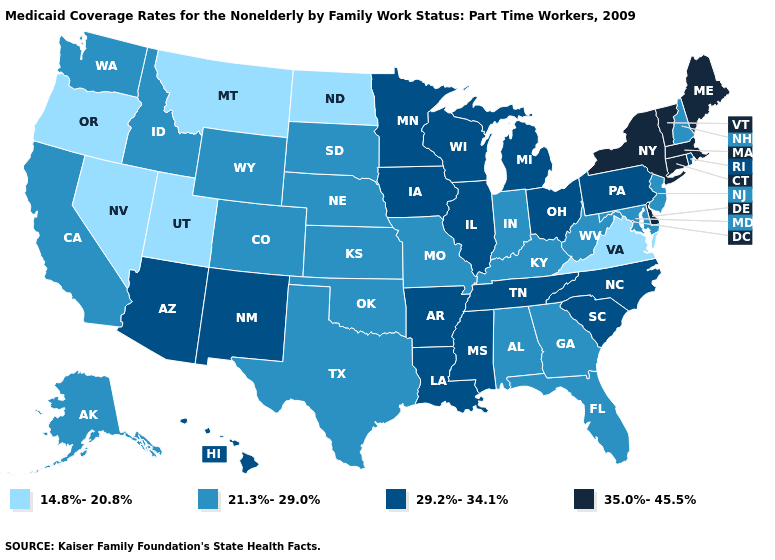Name the states that have a value in the range 14.8%-20.8%?
Answer briefly. Montana, Nevada, North Dakota, Oregon, Utah, Virginia. Name the states that have a value in the range 29.2%-34.1%?
Keep it brief. Arizona, Arkansas, Hawaii, Illinois, Iowa, Louisiana, Michigan, Minnesota, Mississippi, New Mexico, North Carolina, Ohio, Pennsylvania, Rhode Island, South Carolina, Tennessee, Wisconsin. Does Maryland have the lowest value in the South?
Write a very short answer. No. What is the value of South Carolina?
Quick response, please. 29.2%-34.1%. What is the highest value in the Northeast ?
Keep it brief. 35.0%-45.5%. Which states have the lowest value in the South?
Short answer required. Virginia. Among the states that border Texas , which have the highest value?
Concise answer only. Arkansas, Louisiana, New Mexico. Among the states that border Michigan , does Ohio have the lowest value?
Answer briefly. No. Name the states that have a value in the range 21.3%-29.0%?
Quick response, please. Alabama, Alaska, California, Colorado, Florida, Georgia, Idaho, Indiana, Kansas, Kentucky, Maryland, Missouri, Nebraska, New Hampshire, New Jersey, Oklahoma, South Dakota, Texas, Washington, West Virginia, Wyoming. Name the states that have a value in the range 21.3%-29.0%?
Answer briefly. Alabama, Alaska, California, Colorado, Florida, Georgia, Idaho, Indiana, Kansas, Kentucky, Maryland, Missouri, Nebraska, New Hampshire, New Jersey, Oklahoma, South Dakota, Texas, Washington, West Virginia, Wyoming. Name the states that have a value in the range 21.3%-29.0%?
Answer briefly. Alabama, Alaska, California, Colorado, Florida, Georgia, Idaho, Indiana, Kansas, Kentucky, Maryland, Missouri, Nebraska, New Hampshire, New Jersey, Oklahoma, South Dakota, Texas, Washington, West Virginia, Wyoming. What is the value of Florida?
Quick response, please. 21.3%-29.0%. What is the lowest value in the USA?
Quick response, please. 14.8%-20.8%. How many symbols are there in the legend?
Quick response, please. 4. 